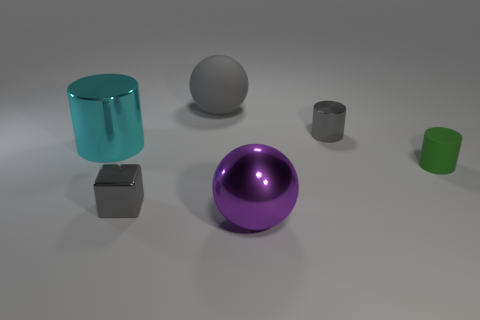There is a tiny cylinder that is on the left side of the small green thing behind the metal sphere; how many tiny cylinders are in front of it?
Your answer should be compact. 1. There is another sphere that is the same size as the purple metallic sphere; what is it made of?
Offer a very short reply. Rubber. Is there another green thing of the same size as the green matte thing?
Your answer should be very brief. No. The large rubber ball is what color?
Offer a very short reply. Gray. There is a tiny metal object left of the ball that is behind the metal block; what is its color?
Offer a very short reply. Gray. The large metallic object that is behind the purple metal ball to the left of the small metal object that is behind the cyan cylinder is what shape?
Make the answer very short. Cylinder. How many large green balls are the same material as the green cylinder?
Offer a terse response. 0. There is a cylinder on the left side of the purple metal sphere; how many small gray metal things are in front of it?
Provide a short and direct response. 1. What number of large brown objects are there?
Your response must be concise. 0. Does the purple thing have the same material as the large ball behind the small green object?
Offer a very short reply. No. 